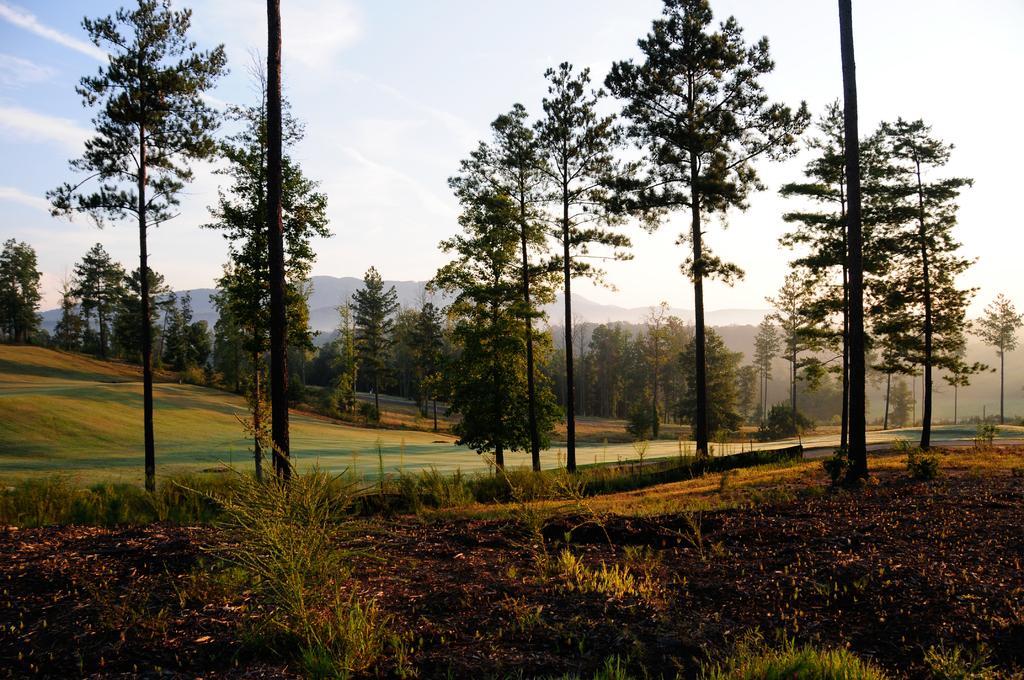How would you summarize this image in a sentence or two? In this image we can see some plants, the bark of the trees, grass and a group of trees. On the backside we can see the hills and the sky which looks cloudy. 